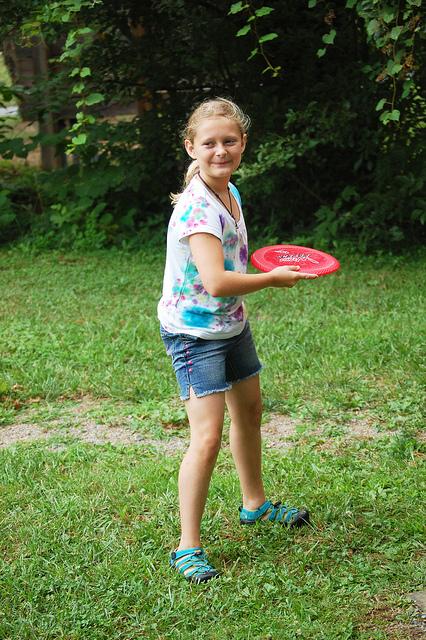Is this an adult or a child?
Short answer required. Child. Is the girl at home?
Be succinct. No. What is this child playing?
Short answer required. Frisbee. Does she have a blue bow in her hair?
Write a very short answer. No. What toy is the girl holding?
Concise answer only. Frisbee. How many frisbees are there?
Be succinct. 1. 